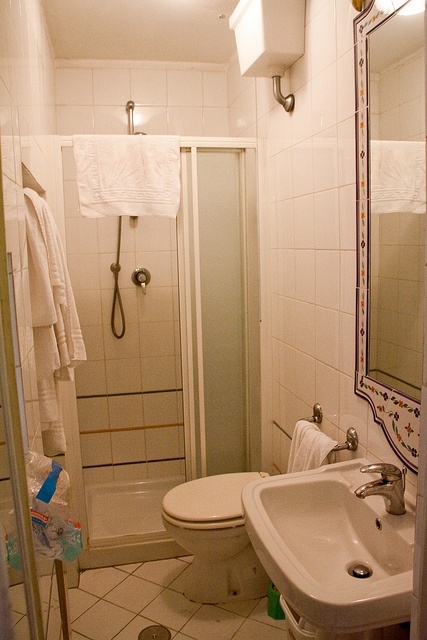Describe the objects in this image and their specific colors. I can see sink in tan and gray tones and toilet in tan and maroon tones in this image. 